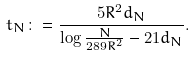Convert formula to latex. <formula><loc_0><loc_0><loc_500><loc_500>t _ { N } \colon = \frac { 5 R ^ { 2 } d _ { N } } { \log \frac { N } { 2 8 9 R ^ { 2 } } - 2 1 d _ { N } } .</formula> 